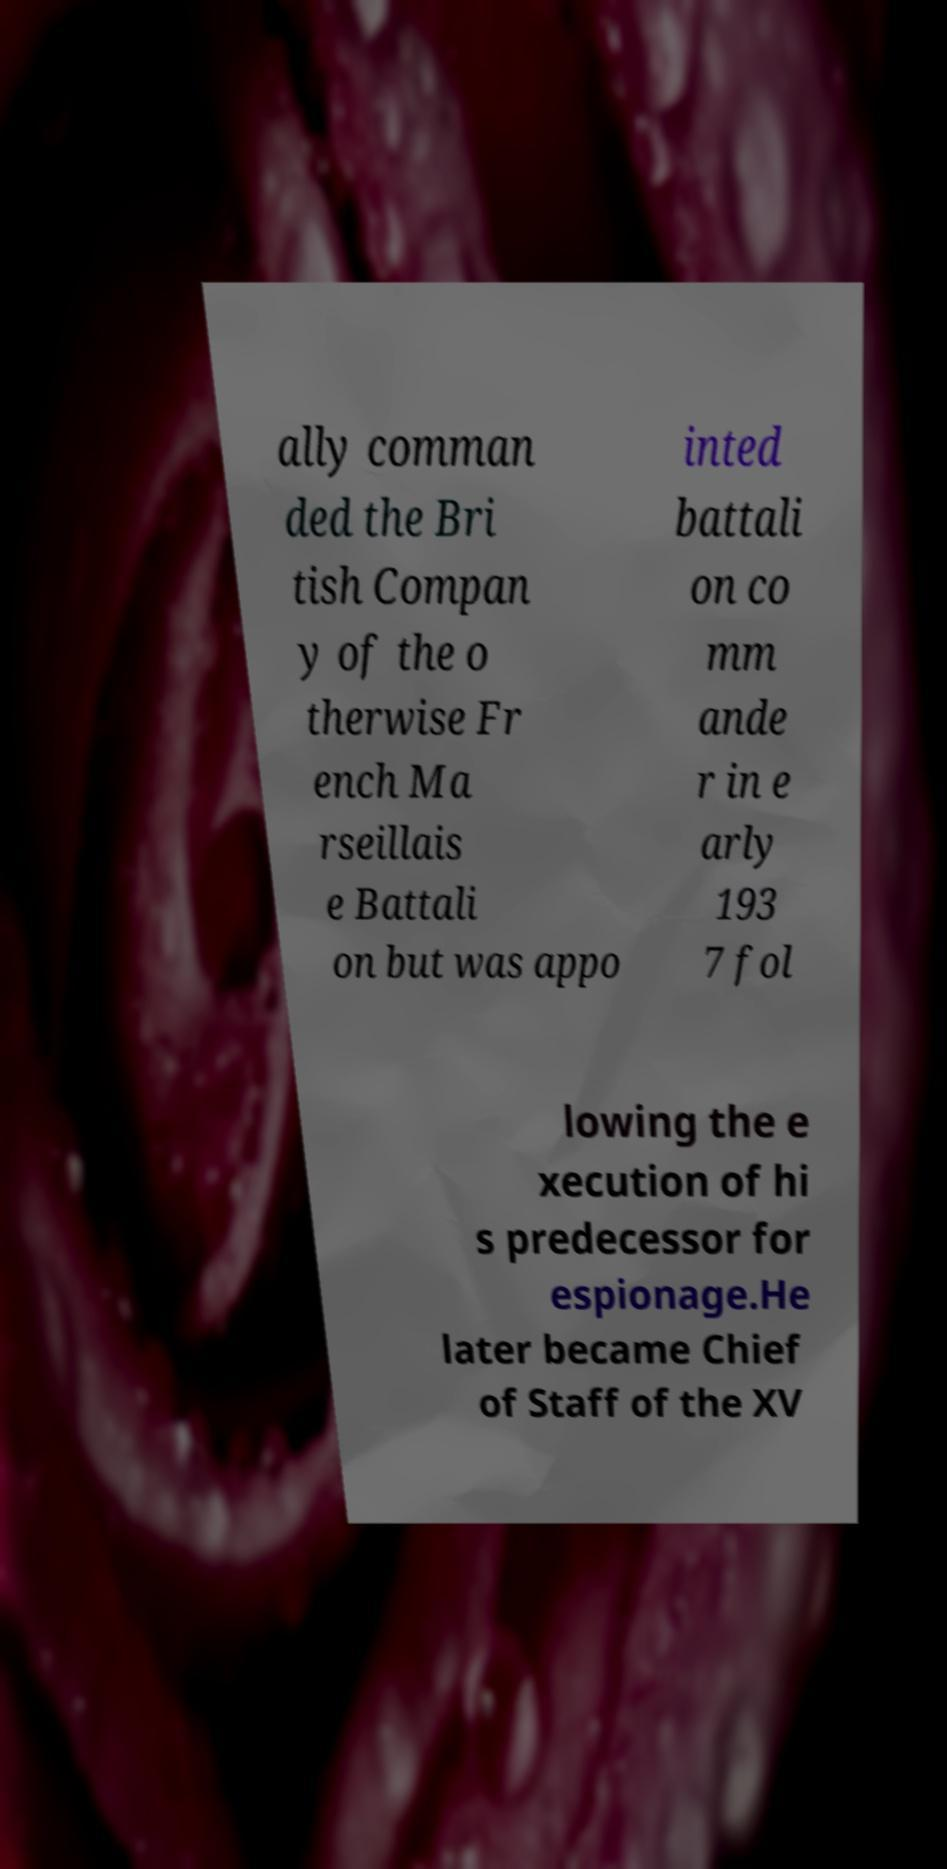What messages or text are displayed in this image? I need them in a readable, typed format. ally comman ded the Bri tish Compan y of the o therwise Fr ench Ma rseillais e Battali on but was appo inted battali on co mm ande r in e arly 193 7 fol lowing the e xecution of hi s predecessor for espionage.He later became Chief of Staff of the XV 